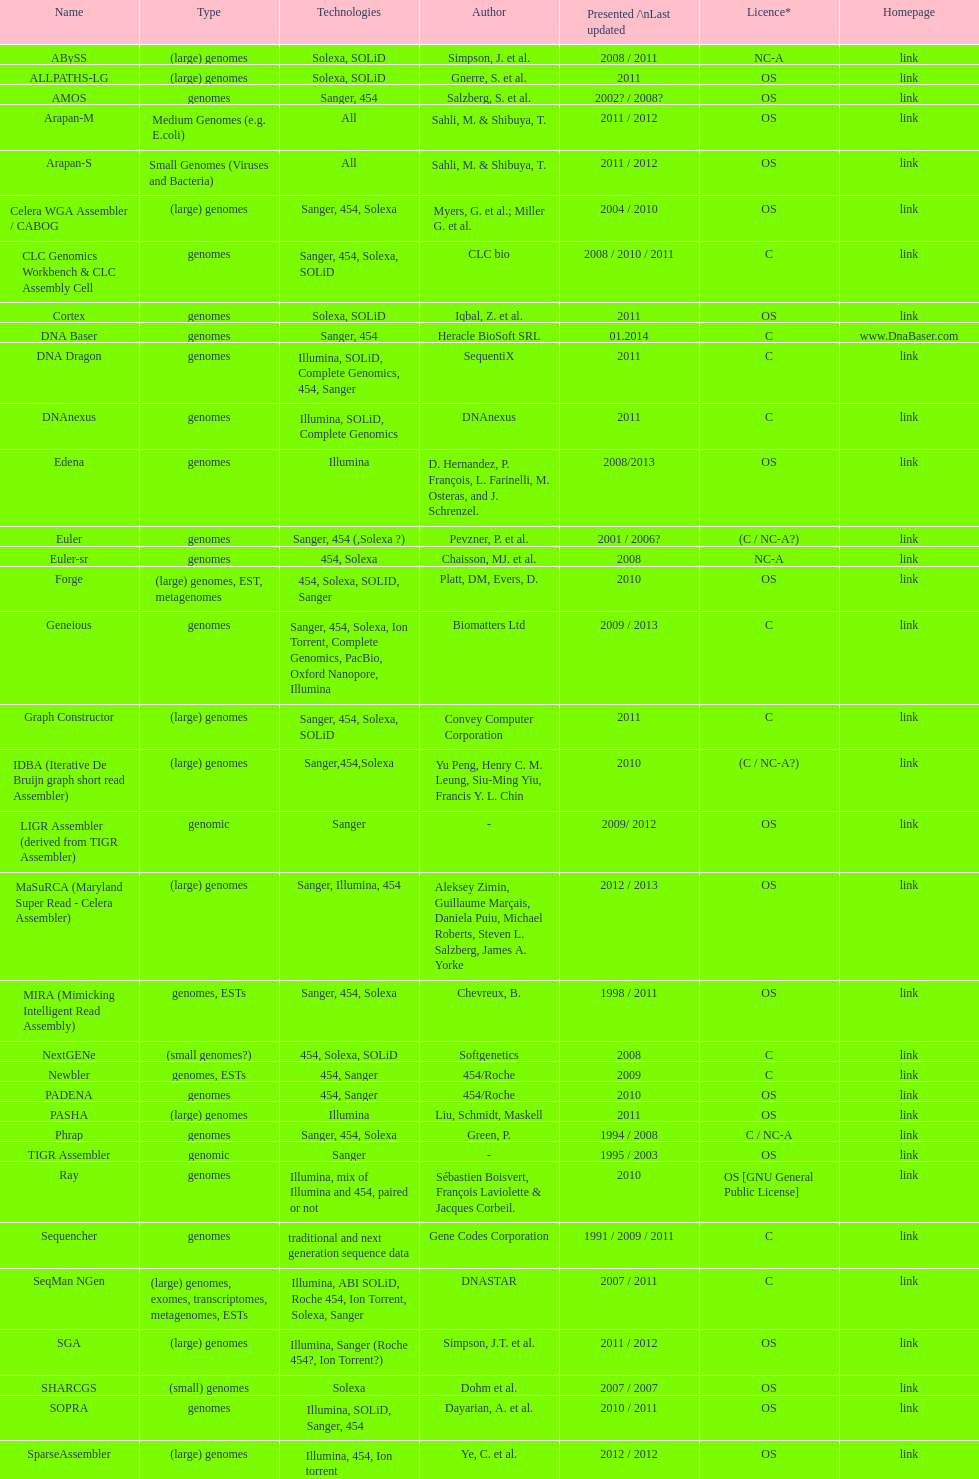Which license is cited more, os or c? OS. 